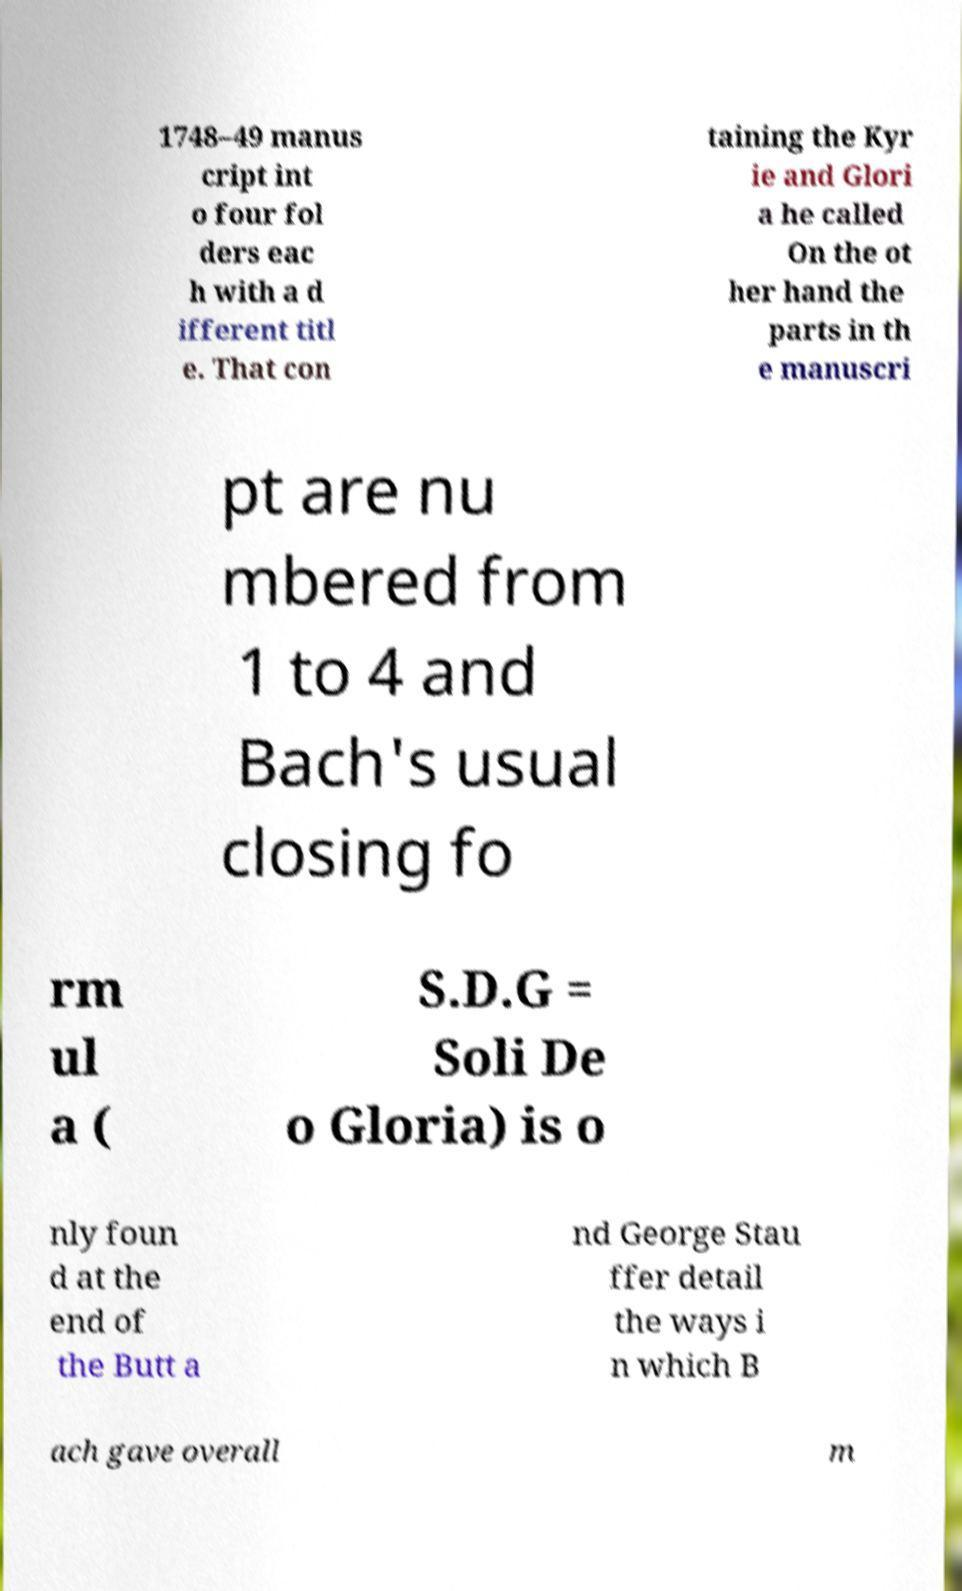For documentation purposes, I need the text within this image transcribed. Could you provide that? 1748–49 manus cript int o four fol ders eac h with a d ifferent titl e. That con taining the Kyr ie and Glori a he called On the ot her hand the parts in th e manuscri pt are nu mbered from 1 to 4 and Bach's usual closing fo rm ul a ( S.D.G = Soli De o Gloria) is o nly foun d at the end of the Butt a nd George Stau ffer detail the ways i n which B ach gave overall m 